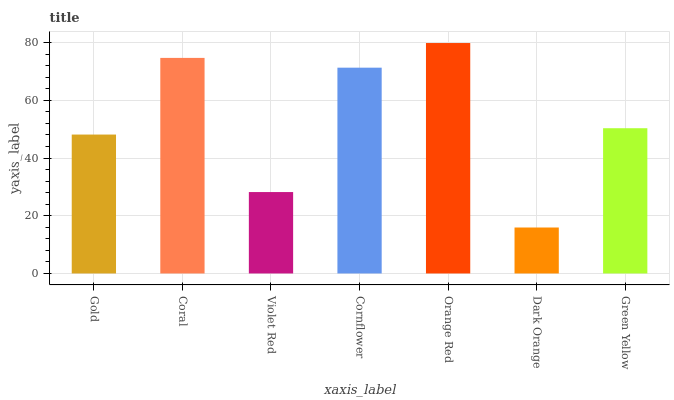Is Dark Orange the minimum?
Answer yes or no. Yes. Is Orange Red the maximum?
Answer yes or no. Yes. Is Coral the minimum?
Answer yes or no. No. Is Coral the maximum?
Answer yes or no. No. Is Coral greater than Gold?
Answer yes or no. Yes. Is Gold less than Coral?
Answer yes or no. Yes. Is Gold greater than Coral?
Answer yes or no. No. Is Coral less than Gold?
Answer yes or no. No. Is Green Yellow the high median?
Answer yes or no. Yes. Is Green Yellow the low median?
Answer yes or no. Yes. Is Dark Orange the high median?
Answer yes or no. No. Is Orange Red the low median?
Answer yes or no. No. 